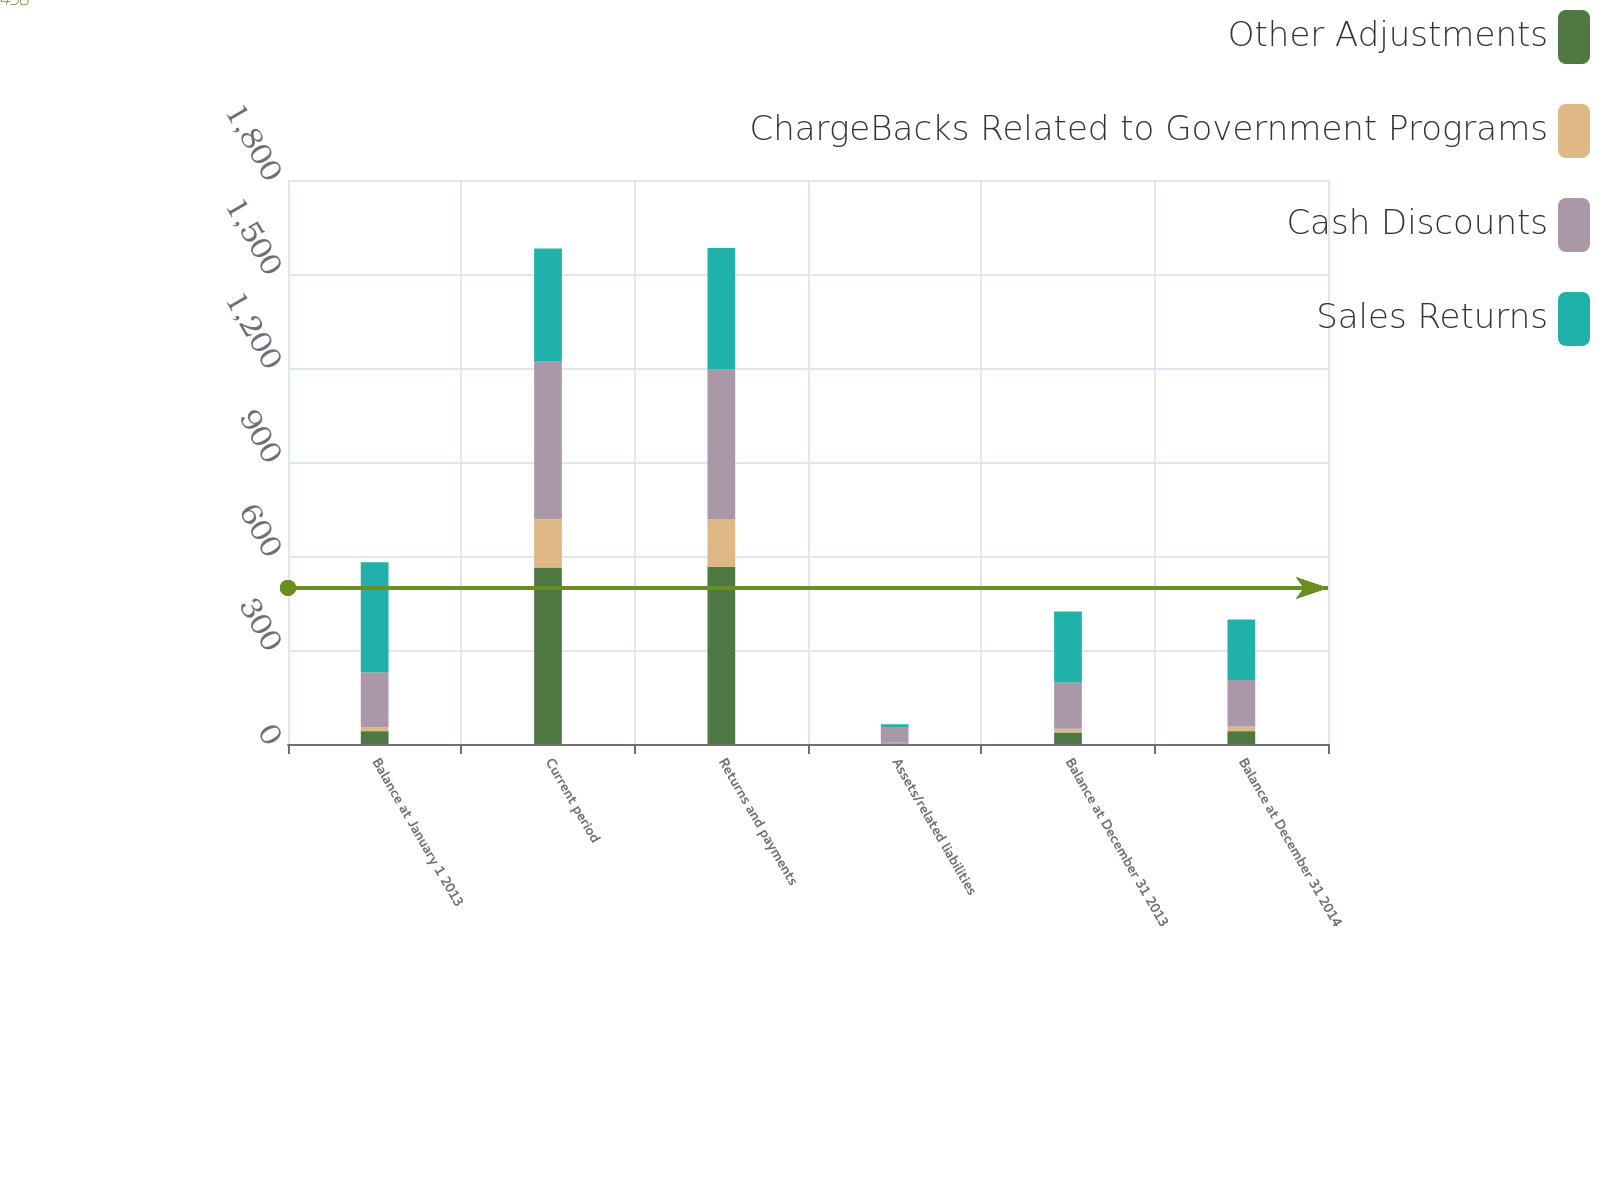Convert chart. <chart><loc_0><loc_0><loc_500><loc_500><stacked_bar_chart><ecel><fcel>Balance at January 1 2013<fcel>Current period<fcel>Returns and payments<fcel>Assets/related liabilities<fcel>Balance at December 31 2013<fcel>Balance at December 31 2014<nl><fcel>Other Adjustments<fcel>41<fcel>563<fcel>565<fcel>2<fcel>37<fcel>41<nl><fcel>ChargeBacks Related to Government Programs<fcel>13<fcel>154<fcel>153<fcel>2<fcel>12<fcel>15<nl><fcel>Cash Discounts<fcel>175<fcel>504<fcel>477<fcel>48<fcel>147<fcel>148<nl><fcel>Sales Returns<fcel>351<fcel>360<fcel>388<fcel>11<fcel>227<fcel>193<nl></chart> 